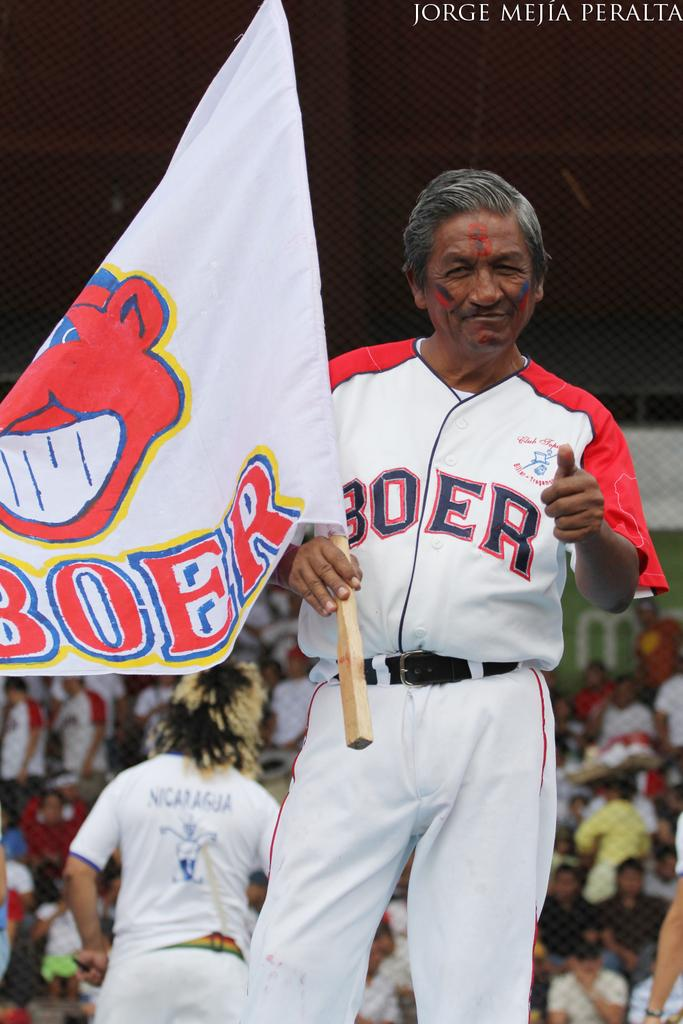<image>
Write a terse but informative summary of the picture. a man holding up a Boer flag and in a Boer jersey 